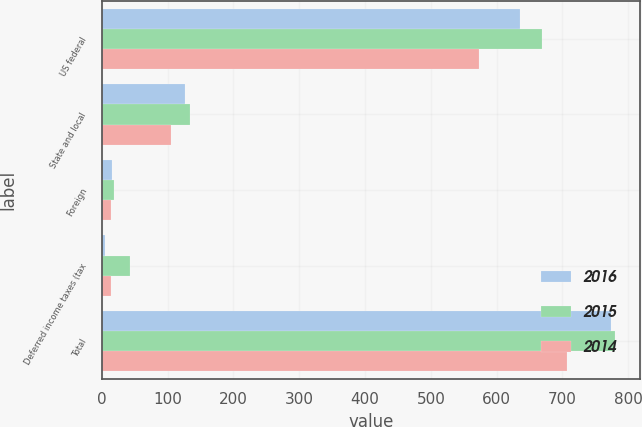<chart> <loc_0><loc_0><loc_500><loc_500><stacked_bar_chart><ecel><fcel>US federal<fcel>State and local<fcel>Foreign<fcel>Deferred income taxes (tax<fcel>Total<nl><fcel>2016<fcel>635.8<fcel>126.8<fcel>16.3<fcel>5.4<fcel>773.5<nl><fcel>2015<fcel>669.5<fcel>134.3<fcel>18.9<fcel>43.3<fcel>779.4<nl><fcel>2014<fcel>573.7<fcel>105.8<fcel>13.5<fcel>13.5<fcel>706.5<nl></chart> 